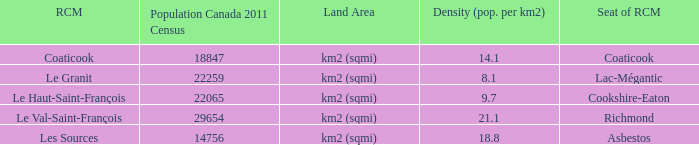What is the RCM that has a density of 9.7? Le Haut-Saint-François. 